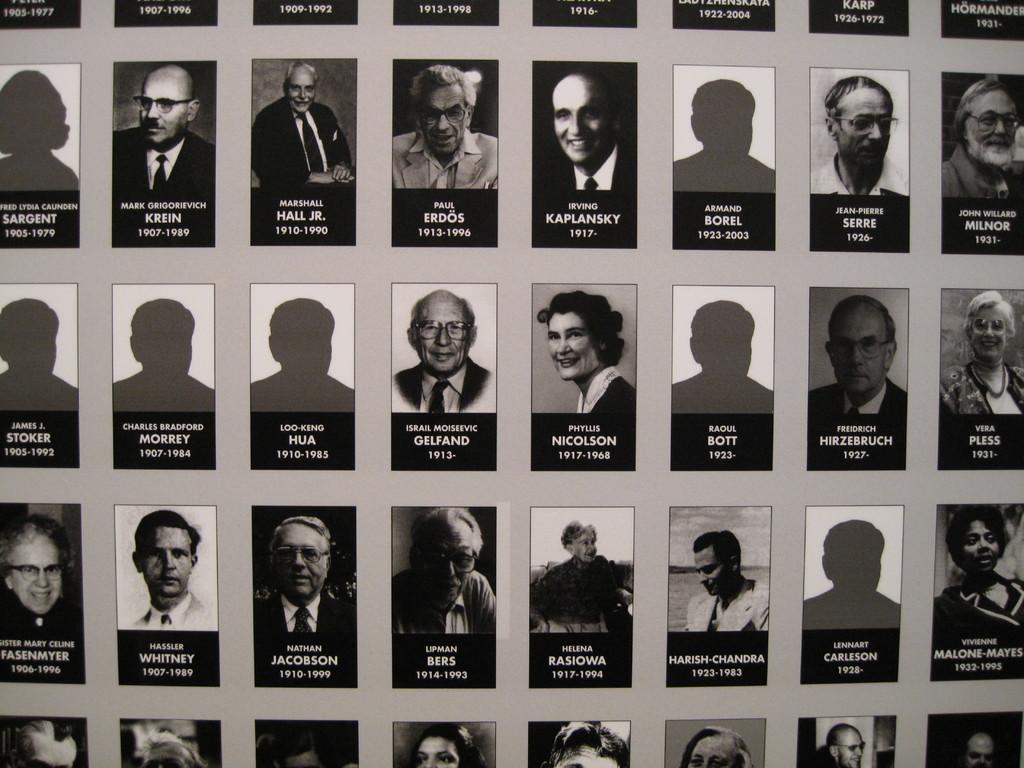In one or two sentences, can you explain what this image depicts? In this picture we can observe many number of passport size photos of the persons with name, birth and death years. We can observe some empty columns without the person's photos. There are men and women in this picture. 